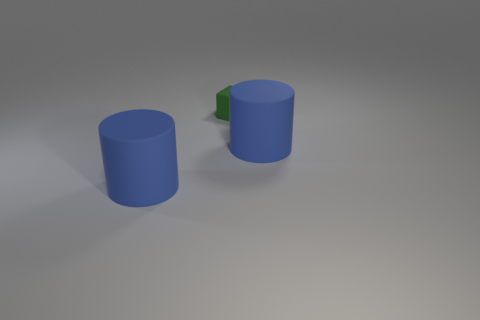What number of metal things are tiny green blocks or cylinders?
Make the answer very short. 0. What number of things are either large matte cylinders or rubber blocks?
Your answer should be very brief. 3. How many tiny things are blue matte objects or blue metallic cylinders?
Keep it short and to the point. 0. What number of other objects are there of the same color as the small rubber thing?
Provide a short and direct response. 0. What number of small cubes are on the left side of the large blue rubber thing that is to the right of the large blue thing left of the small green rubber thing?
Ensure brevity in your answer.  1. There is a rubber object that is to the left of the green matte cube; does it have the same size as the cube?
Your answer should be compact. No. Are there fewer blue rubber cylinders that are to the left of the tiny cube than blue things?
Provide a succinct answer. Yes. How many big objects have the same material as the tiny green object?
Provide a short and direct response. 2. What is the shape of the small green rubber object?
Make the answer very short. Cube. There is a blue thing that is on the left side of the rubber cube; what material is it?
Keep it short and to the point. Rubber. 